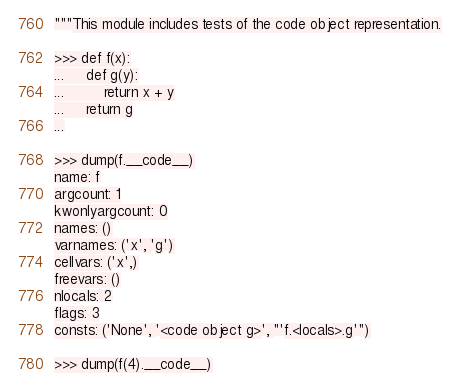<code> <loc_0><loc_0><loc_500><loc_500><_Python_>"""This module includes tests of the code object representation.

>>> def f(x):
...     def g(y):
...         return x + y
...     return g
...

>>> dump(f.__code__)
name: f
argcount: 1
kwonlyargcount: 0
names: ()
varnames: ('x', 'g')
cellvars: ('x',)
freevars: ()
nlocals: 2
flags: 3
consts: ('None', '<code object g>', "'f.<locals>.g'")

>>> dump(f(4).__code__)</code> 